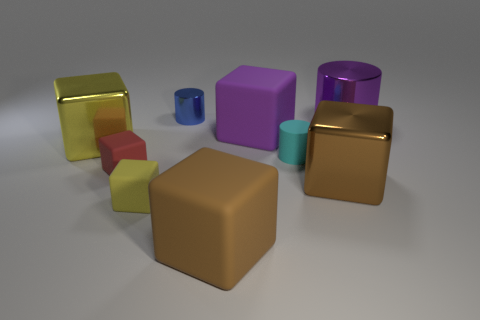Subtract all tiny yellow blocks. How many blocks are left? 5 Subtract all cylinders. How many objects are left? 6 Subtract all red cubes. How many cubes are left? 5 Subtract all green balls. How many gray cubes are left? 0 Subtract 2 yellow blocks. How many objects are left? 7 Subtract 1 cylinders. How many cylinders are left? 2 Subtract all yellow blocks. Subtract all brown balls. How many blocks are left? 4 Subtract all large green things. Subtract all tiny blue shiny cylinders. How many objects are left? 8 Add 6 yellow metallic cubes. How many yellow metallic cubes are left? 7 Add 5 tiny gray cubes. How many tiny gray cubes exist? 5 